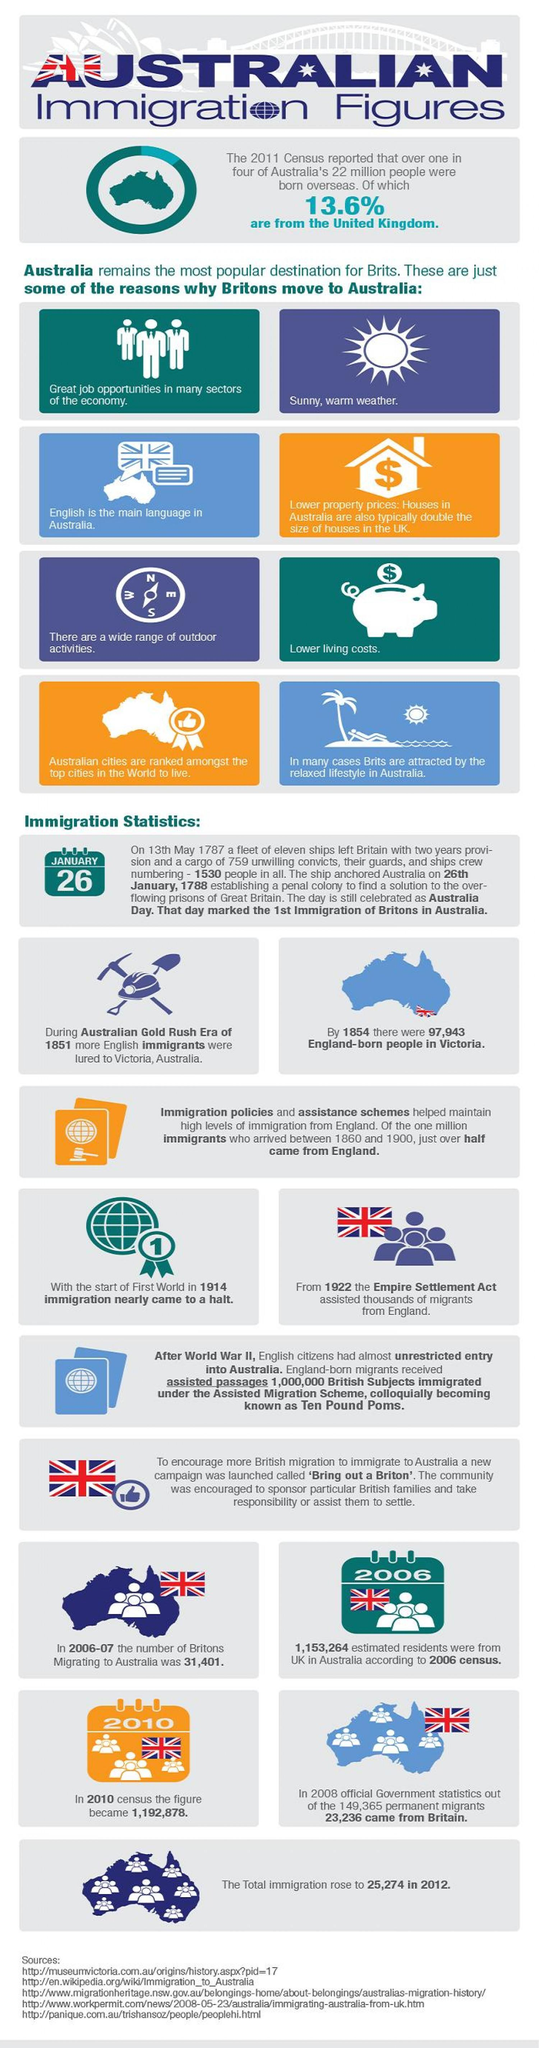What percent of Australians are born overseas and are not from the United Kingdom?
Answer the question with a short phrase. 86.4 Gold Rush Era of Australia happened in which year? 1851 How many Britons were migrated to Australia from 2006 to 2007 period? 31,401 In which year more England born people were migrated to Australia? 1854 How many reasons has been listed to show why Britons move to Australia? 8 When did the immigration to Australia came closer to an abrupt stop? 1914 